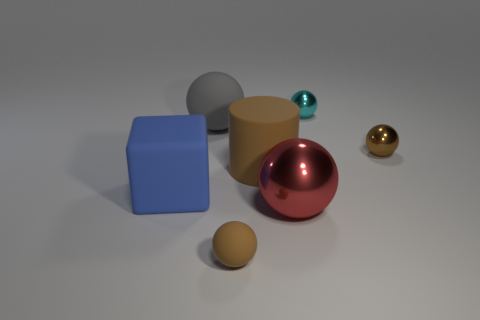The red object that is the same shape as the small cyan metal object is what size?
Your answer should be very brief. Large. There is a gray sphere; are there any big red spheres left of it?
Your response must be concise. No. Are there an equal number of big metal objects to the left of the blue thing and brown cylinders?
Provide a succinct answer. No. There is a rubber cube that is behind the small thing that is in front of the big metallic sphere; are there any metal objects behind it?
Offer a very short reply. Yes. What material is the big brown object?
Your response must be concise. Rubber. How many other objects are the same shape as the large red object?
Make the answer very short. 4. Do the cyan thing and the gray object have the same shape?
Provide a short and direct response. Yes. How many things are tiny brown things to the right of the cylinder or objects that are left of the cyan thing?
Give a very brief answer. 6. How many things are large cyan balls or large brown objects?
Provide a short and direct response. 1. How many big balls are in front of the small thing right of the tiny cyan thing?
Keep it short and to the point. 1. 